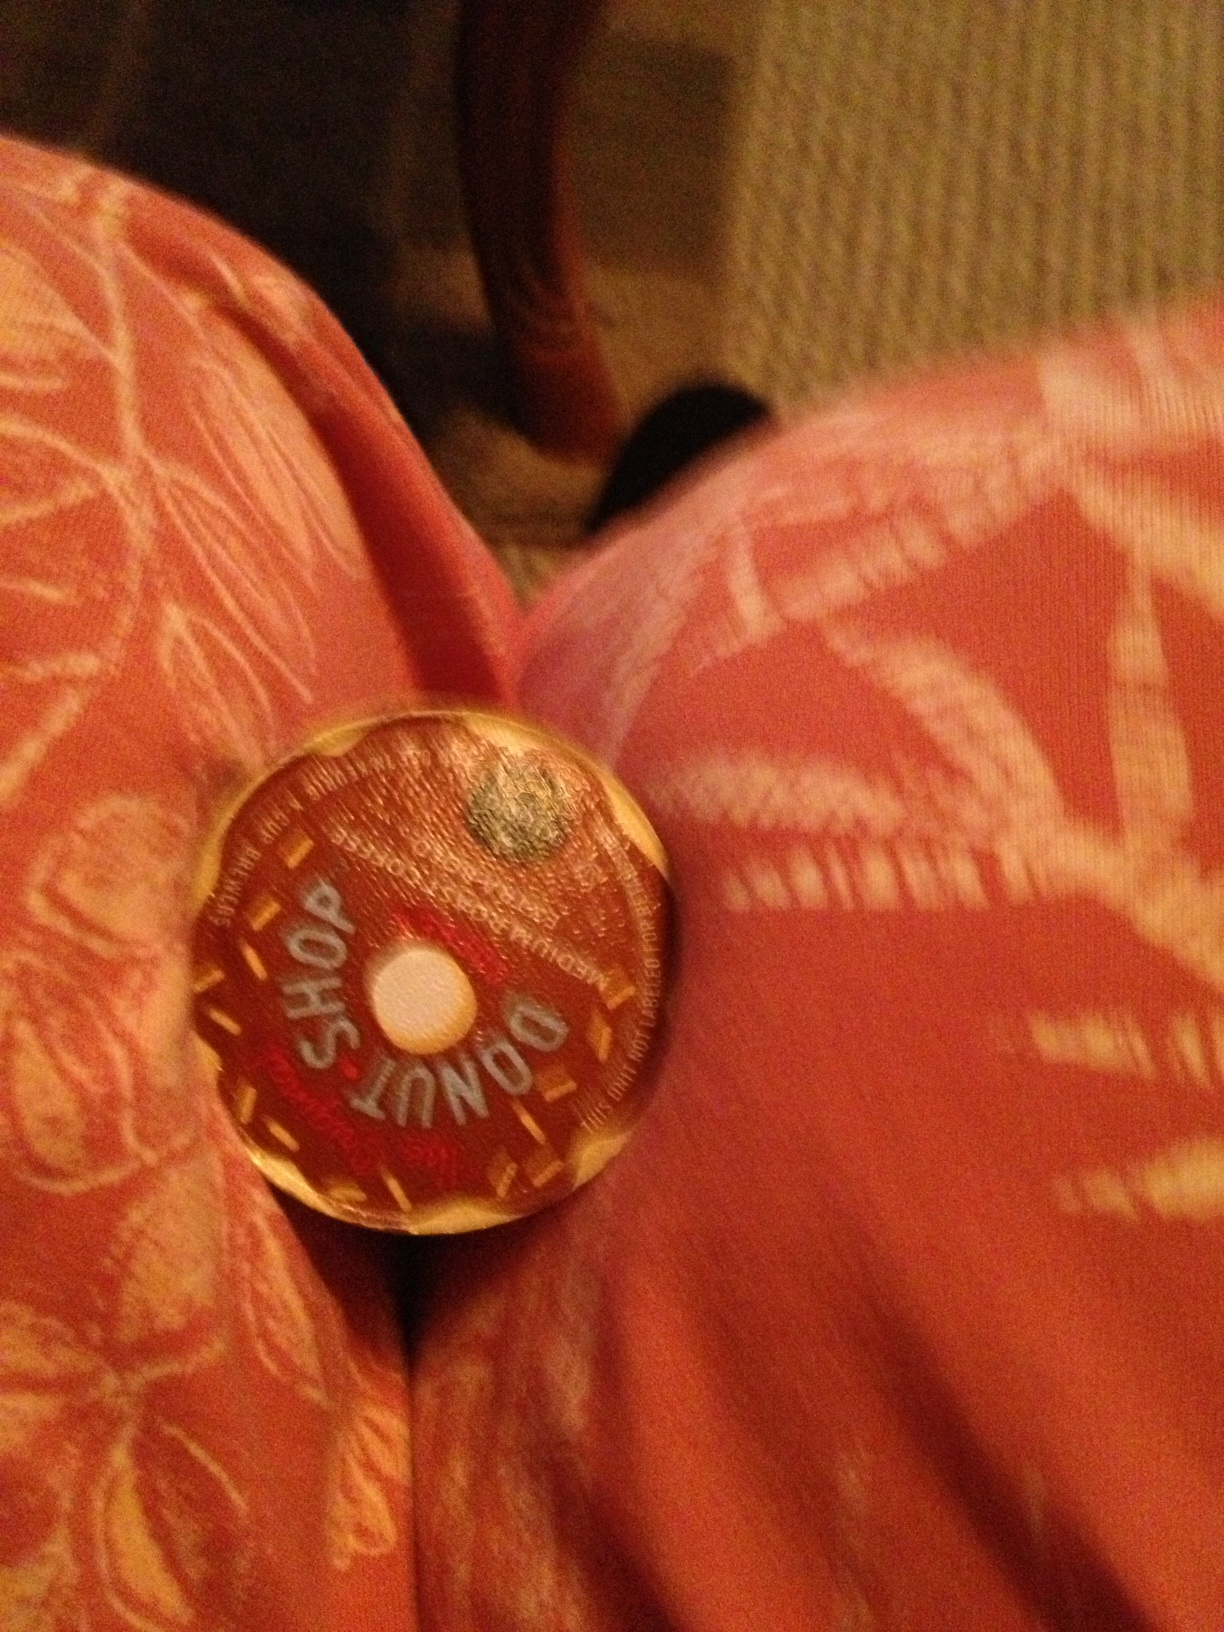You're hosting a casual brunch at home. How does Donut Shop coffee fit into the picture? Hosting a casual brunch? Donut Shop coffee is the perfect addition to your menu. It's quick to prepare, allowing you to spend more time with your guests, and its sweet, inviting taste complements a variety of brunch items like pancakes, muffins, and, of course, donuts. The comforting aroma of freshly brewed coffee fills the room, creating a cozy and welcoming atmosphere that invites guests to relax and enjoy the meal. 